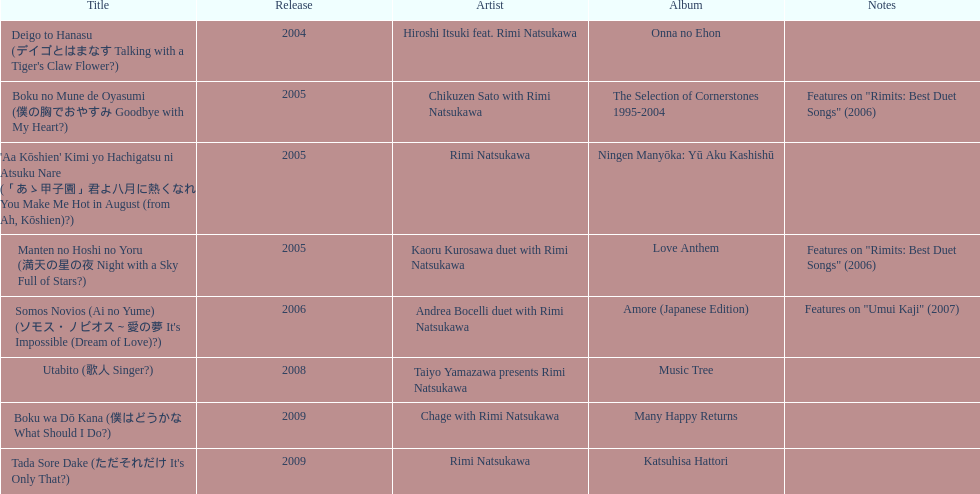Which track featured this artist post-utabito? Boku wa Dō Kana. 